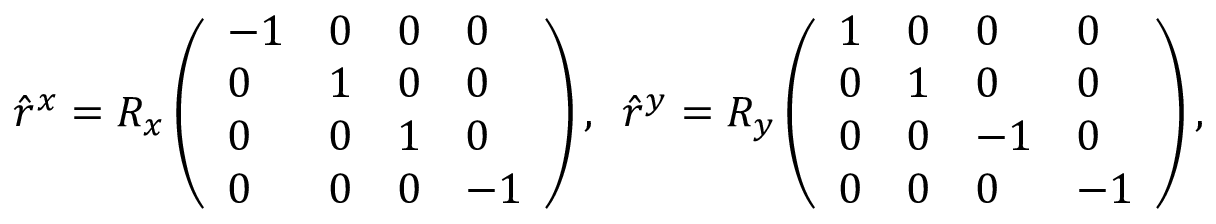Convert formula to latex. <formula><loc_0><loc_0><loc_500><loc_500>\hat { r } ^ { x } = R _ { x } \left ( \begin{array} { l l l l } { - 1 } & { 0 } & { 0 } & { 0 } \\ { 0 } & { 1 } & { 0 } & { 0 } \\ { 0 } & { 0 } & { 1 } & { 0 } \\ { 0 } & { 0 } & { 0 } & { - 1 } \end{array} \right ) , \, \hat { r } ^ { y } = R _ { y } \left ( \begin{array} { l l l l } { 1 } & { 0 } & { 0 } & { 0 } \\ { 0 } & { 1 } & { 0 } & { 0 } \\ { 0 } & { 0 } & { - 1 } & { 0 } \\ { 0 } & { 0 } & { 0 } & { - 1 } \end{array} \right ) ,</formula> 